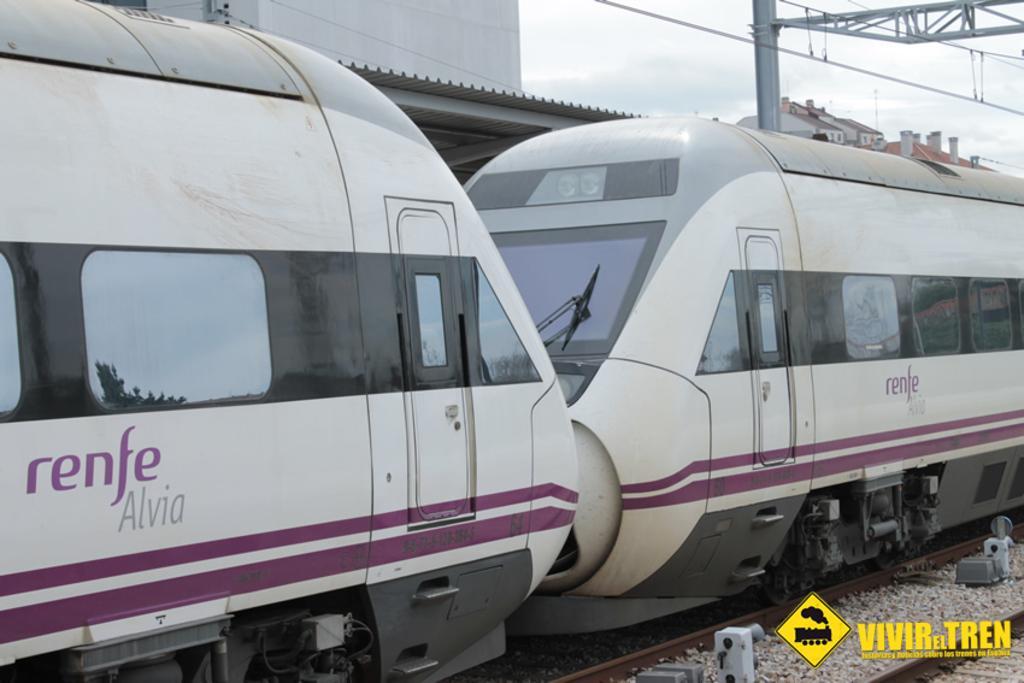Can you describe this image briefly? In this image I can see railway tracks and on it I can see white colour train. I can also something is written on this train. In background I can see few buildings, a pole, few wires and the sky. Here I can see watermark. 